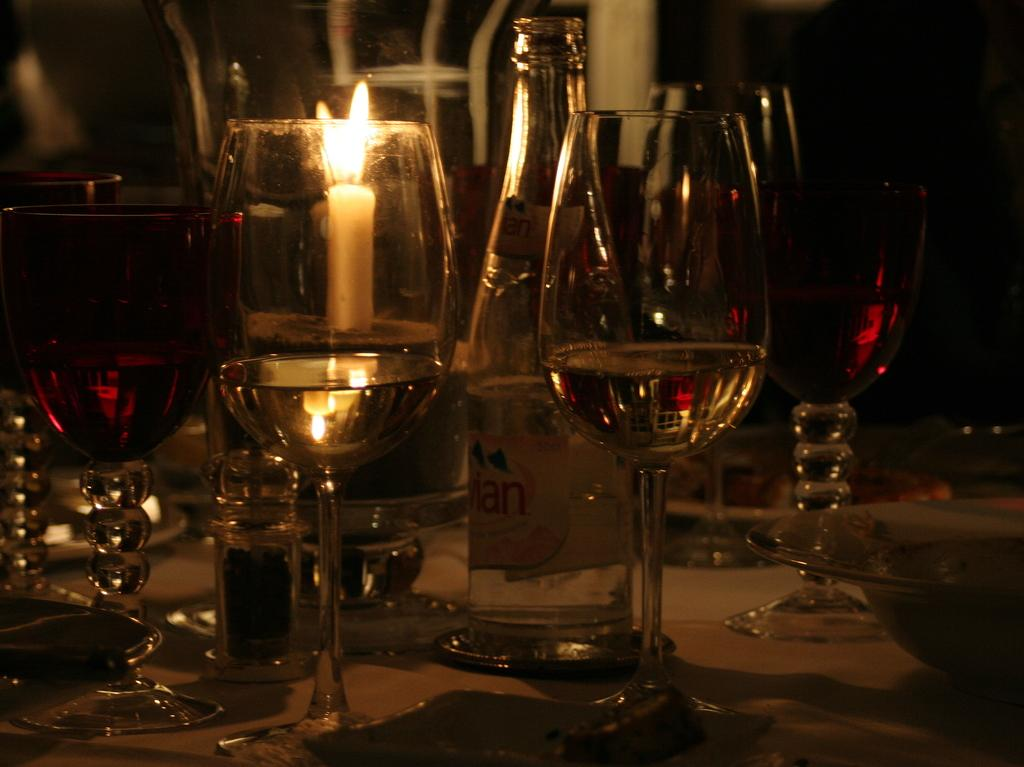What type of objects can be seen in the image? There are glasses, a wine bottle, and a candle in the image. What might be used for drinking in the image? The glasses in the image might be used for drinking. What is the purpose of the wine bottle in the image? The wine bottle in the image is likely used for holding wine. What is the purpose of the candle in the image? The candle in the image might be used for providing light or creating a certain ambiance. Can you tell me how many fingers the girl has in the image? There is no girl present in the image, so it is not possible to determine the number of fingers she might have. 